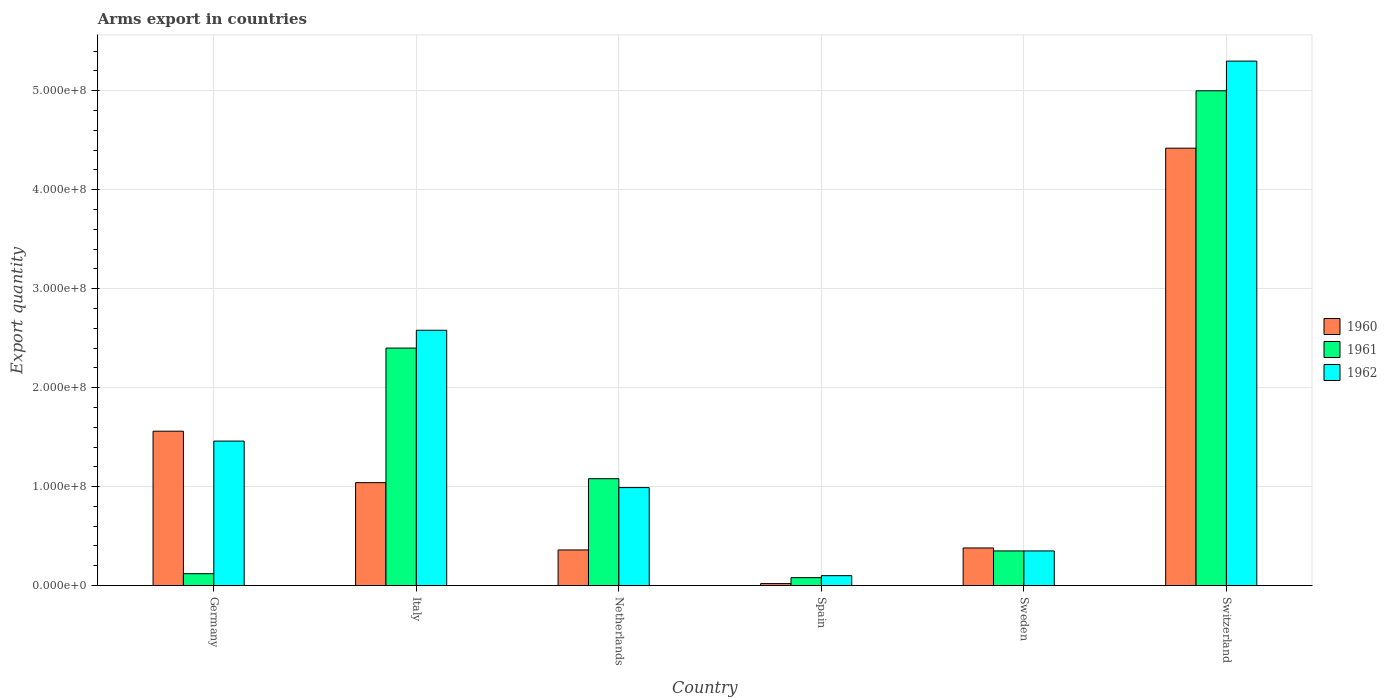How many different coloured bars are there?
Give a very brief answer. 3. How many groups of bars are there?
Offer a very short reply. 6. Are the number of bars on each tick of the X-axis equal?
Your response must be concise. Yes. How many bars are there on the 2nd tick from the left?
Your answer should be compact. 3. What is the label of the 2nd group of bars from the left?
Your answer should be very brief. Italy. What is the total arms export in 1962 in Germany?
Ensure brevity in your answer.  1.46e+08. Across all countries, what is the maximum total arms export in 1962?
Give a very brief answer. 5.30e+08. In which country was the total arms export in 1962 maximum?
Your answer should be compact. Switzerland. In which country was the total arms export in 1961 minimum?
Make the answer very short. Spain. What is the total total arms export in 1962 in the graph?
Offer a terse response. 1.08e+09. What is the difference between the total arms export in 1960 in Spain and that in Sweden?
Your response must be concise. -3.60e+07. What is the difference between the total arms export in 1962 in Italy and the total arms export in 1961 in Germany?
Keep it short and to the point. 2.46e+08. What is the average total arms export in 1961 per country?
Offer a terse response. 1.50e+08. What is the difference between the total arms export of/in 1962 and total arms export of/in 1960 in Italy?
Your answer should be compact. 1.54e+08. What is the ratio of the total arms export in 1962 in Netherlands to that in Switzerland?
Keep it short and to the point. 0.19. Is the total arms export in 1962 in Germany less than that in Spain?
Provide a short and direct response. No. Is the difference between the total arms export in 1962 in Italy and Netherlands greater than the difference between the total arms export in 1960 in Italy and Netherlands?
Offer a terse response. Yes. What is the difference between the highest and the second highest total arms export in 1962?
Your response must be concise. 3.84e+08. What is the difference between the highest and the lowest total arms export in 1960?
Your answer should be very brief. 4.40e+08. In how many countries, is the total arms export in 1961 greater than the average total arms export in 1961 taken over all countries?
Provide a short and direct response. 2. Is the sum of the total arms export in 1960 in Sweden and Switzerland greater than the maximum total arms export in 1962 across all countries?
Give a very brief answer. No. What does the 2nd bar from the right in Switzerland represents?
Provide a short and direct response. 1961. Are all the bars in the graph horizontal?
Provide a short and direct response. No. How many countries are there in the graph?
Provide a succinct answer. 6. What is the difference between two consecutive major ticks on the Y-axis?
Offer a very short reply. 1.00e+08. Are the values on the major ticks of Y-axis written in scientific E-notation?
Offer a very short reply. Yes. Does the graph contain grids?
Offer a terse response. Yes. Where does the legend appear in the graph?
Make the answer very short. Center right. What is the title of the graph?
Offer a terse response. Arms export in countries. What is the label or title of the X-axis?
Provide a short and direct response. Country. What is the label or title of the Y-axis?
Provide a succinct answer. Export quantity. What is the Export quantity of 1960 in Germany?
Your response must be concise. 1.56e+08. What is the Export quantity of 1961 in Germany?
Provide a succinct answer. 1.20e+07. What is the Export quantity of 1962 in Germany?
Make the answer very short. 1.46e+08. What is the Export quantity in 1960 in Italy?
Your answer should be very brief. 1.04e+08. What is the Export quantity of 1961 in Italy?
Your answer should be very brief. 2.40e+08. What is the Export quantity of 1962 in Italy?
Offer a very short reply. 2.58e+08. What is the Export quantity of 1960 in Netherlands?
Offer a terse response. 3.60e+07. What is the Export quantity in 1961 in Netherlands?
Provide a short and direct response. 1.08e+08. What is the Export quantity of 1962 in Netherlands?
Offer a terse response. 9.90e+07. What is the Export quantity in 1960 in Spain?
Provide a succinct answer. 2.00e+06. What is the Export quantity in 1960 in Sweden?
Offer a very short reply. 3.80e+07. What is the Export quantity in 1961 in Sweden?
Your answer should be very brief. 3.50e+07. What is the Export quantity of 1962 in Sweden?
Keep it short and to the point. 3.50e+07. What is the Export quantity of 1960 in Switzerland?
Make the answer very short. 4.42e+08. What is the Export quantity in 1961 in Switzerland?
Your answer should be very brief. 5.00e+08. What is the Export quantity of 1962 in Switzerland?
Your answer should be compact. 5.30e+08. Across all countries, what is the maximum Export quantity of 1960?
Provide a short and direct response. 4.42e+08. Across all countries, what is the maximum Export quantity of 1962?
Your answer should be compact. 5.30e+08. Across all countries, what is the minimum Export quantity in 1960?
Your answer should be very brief. 2.00e+06. Across all countries, what is the minimum Export quantity in 1961?
Offer a terse response. 8.00e+06. Across all countries, what is the minimum Export quantity in 1962?
Provide a succinct answer. 1.00e+07. What is the total Export quantity in 1960 in the graph?
Provide a short and direct response. 7.78e+08. What is the total Export quantity in 1961 in the graph?
Make the answer very short. 9.03e+08. What is the total Export quantity in 1962 in the graph?
Your answer should be very brief. 1.08e+09. What is the difference between the Export quantity in 1960 in Germany and that in Italy?
Ensure brevity in your answer.  5.20e+07. What is the difference between the Export quantity of 1961 in Germany and that in Italy?
Give a very brief answer. -2.28e+08. What is the difference between the Export quantity of 1962 in Germany and that in Italy?
Your answer should be very brief. -1.12e+08. What is the difference between the Export quantity in 1960 in Germany and that in Netherlands?
Offer a terse response. 1.20e+08. What is the difference between the Export quantity in 1961 in Germany and that in Netherlands?
Keep it short and to the point. -9.60e+07. What is the difference between the Export quantity of 1962 in Germany and that in Netherlands?
Your response must be concise. 4.70e+07. What is the difference between the Export quantity of 1960 in Germany and that in Spain?
Ensure brevity in your answer.  1.54e+08. What is the difference between the Export quantity of 1962 in Germany and that in Spain?
Offer a terse response. 1.36e+08. What is the difference between the Export quantity in 1960 in Germany and that in Sweden?
Offer a very short reply. 1.18e+08. What is the difference between the Export quantity of 1961 in Germany and that in Sweden?
Your response must be concise. -2.30e+07. What is the difference between the Export quantity of 1962 in Germany and that in Sweden?
Your response must be concise. 1.11e+08. What is the difference between the Export quantity of 1960 in Germany and that in Switzerland?
Ensure brevity in your answer.  -2.86e+08. What is the difference between the Export quantity in 1961 in Germany and that in Switzerland?
Offer a terse response. -4.88e+08. What is the difference between the Export quantity in 1962 in Germany and that in Switzerland?
Keep it short and to the point. -3.84e+08. What is the difference between the Export quantity of 1960 in Italy and that in Netherlands?
Make the answer very short. 6.80e+07. What is the difference between the Export quantity in 1961 in Italy and that in Netherlands?
Your response must be concise. 1.32e+08. What is the difference between the Export quantity of 1962 in Italy and that in Netherlands?
Your response must be concise. 1.59e+08. What is the difference between the Export quantity in 1960 in Italy and that in Spain?
Your answer should be compact. 1.02e+08. What is the difference between the Export quantity in 1961 in Italy and that in Spain?
Offer a terse response. 2.32e+08. What is the difference between the Export quantity in 1962 in Italy and that in Spain?
Your answer should be very brief. 2.48e+08. What is the difference between the Export quantity in 1960 in Italy and that in Sweden?
Offer a very short reply. 6.60e+07. What is the difference between the Export quantity of 1961 in Italy and that in Sweden?
Ensure brevity in your answer.  2.05e+08. What is the difference between the Export quantity of 1962 in Italy and that in Sweden?
Your response must be concise. 2.23e+08. What is the difference between the Export quantity of 1960 in Italy and that in Switzerland?
Provide a short and direct response. -3.38e+08. What is the difference between the Export quantity of 1961 in Italy and that in Switzerland?
Provide a short and direct response. -2.60e+08. What is the difference between the Export quantity in 1962 in Italy and that in Switzerland?
Provide a succinct answer. -2.72e+08. What is the difference between the Export quantity of 1960 in Netherlands and that in Spain?
Keep it short and to the point. 3.40e+07. What is the difference between the Export quantity in 1962 in Netherlands and that in Spain?
Keep it short and to the point. 8.90e+07. What is the difference between the Export quantity in 1961 in Netherlands and that in Sweden?
Your response must be concise. 7.30e+07. What is the difference between the Export quantity of 1962 in Netherlands and that in Sweden?
Ensure brevity in your answer.  6.40e+07. What is the difference between the Export quantity of 1960 in Netherlands and that in Switzerland?
Ensure brevity in your answer.  -4.06e+08. What is the difference between the Export quantity of 1961 in Netherlands and that in Switzerland?
Provide a short and direct response. -3.92e+08. What is the difference between the Export quantity of 1962 in Netherlands and that in Switzerland?
Provide a succinct answer. -4.31e+08. What is the difference between the Export quantity in 1960 in Spain and that in Sweden?
Your response must be concise. -3.60e+07. What is the difference between the Export quantity in 1961 in Spain and that in Sweden?
Your answer should be compact. -2.70e+07. What is the difference between the Export quantity of 1962 in Spain and that in Sweden?
Make the answer very short. -2.50e+07. What is the difference between the Export quantity of 1960 in Spain and that in Switzerland?
Provide a short and direct response. -4.40e+08. What is the difference between the Export quantity in 1961 in Spain and that in Switzerland?
Your answer should be very brief. -4.92e+08. What is the difference between the Export quantity in 1962 in Spain and that in Switzerland?
Offer a very short reply. -5.20e+08. What is the difference between the Export quantity in 1960 in Sweden and that in Switzerland?
Your response must be concise. -4.04e+08. What is the difference between the Export quantity in 1961 in Sweden and that in Switzerland?
Ensure brevity in your answer.  -4.65e+08. What is the difference between the Export quantity of 1962 in Sweden and that in Switzerland?
Offer a very short reply. -4.95e+08. What is the difference between the Export quantity in 1960 in Germany and the Export quantity in 1961 in Italy?
Make the answer very short. -8.40e+07. What is the difference between the Export quantity of 1960 in Germany and the Export quantity of 1962 in Italy?
Your response must be concise. -1.02e+08. What is the difference between the Export quantity of 1961 in Germany and the Export quantity of 1962 in Italy?
Make the answer very short. -2.46e+08. What is the difference between the Export quantity in 1960 in Germany and the Export quantity in 1961 in Netherlands?
Offer a terse response. 4.80e+07. What is the difference between the Export quantity of 1960 in Germany and the Export quantity of 1962 in Netherlands?
Offer a very short reply. 5.70e+07. What is the difference between the Export quantity in 1961 in Germany and the Export quantity in 1962 in Netherlands?
Provide a succinct answer. -8.70e+07. What is the difference between the Export quantity in 1960 in Germany and the Export quantity in 1961 in Spain?
Your answer should be very brief. 1.48e+08. What is the difference between the Export quantity of 1960 in Germany and the Export quantity of 1962 in Spain?
Keep it short and to the point. 1.46e+08. What is the difference between the Export quantity in 1961 in Germany and the Export quantity in 1962 in Spain?
Offer a very short reply. 2.00e+06. What is the difference between the Export quantity in 1960 in Germany and the Export quantity in 1961 in Sweden?
Your answer should be very brief. 1.21e+08. What is the difference between the Export quantity in 1960 in Germany and the Export quantity in 1962 in Sweden?
Offer a very short reply. 1.21e+08. What is the difference between the Export quantity in 1961 in Germany and the Export quantity in 1962 in Sweden?
Give a very brief answer. -2.30e+07. What is the difference between the Export quantity in 1960 in Germany and the Export quantity in 1961 in Switzerland?
Give a very brief answer. -3.44e+08. What is the difference between the Export quantity of 1960 in Germany and the Export quantity of 1962 in Switzerland?
Your answer should be compact. -3.74e+08. What is the difference between the Export quantity of 1961 in Germany and the Export quantity of 1962 in Switzerland?
Your answer should be compact. -5.18e+08. What is the difference between the Export quantity of 1961 in Italy and the Export quantity of 1962 in Netherlands?
Your answer should be compact. 1.41e+08. What is the difference between the Export quantity in 1960 in Italy and the Export quantity in 1961 in Spain?
Provide a succinct answer. 9.60e+07. What is the difference between the Export quantity of 1960 in Italy and the Export quantity of 1962 in Spain?
Your response must be concise. 9.40e+07. What is the difference between the Export quantity in 1961 in Italy and the Export quantity in 1962 in Spain?
Make the answer very short. 2.30e+08. What is the difference between the Export quantity of 1960 in Italy and the Export quantity of 1961 in Sweden?
Give a very brief answer. 6.90e+07. What is the difference between the Export quantity in 1960 in Italy and the Export quantity in 1962 in Sweden?
Your answer should be very brief. 6.90e+07. What is the difference between the Export quantity of 1961 in Italy and the Export quantity of 1962 in Sweden?
Provide a succinct answer. 2.05e+08. What is the difference between the Export quantity in 1960 in Italy and the Export quantity in 1961 in Switzerland?
Give a very brief answer. -3.96e+08. What is the difference between the Export quantity in 1960 in Italy and the Export quantity in 1962 in Switzerland?
Your answer should be compact. -4.26e+08. What is the difference between the Export quantity in 1961 in Italy and the Export quantity in 1962 in Switzerland?
Offer a terse response. -2.90e+08. What is the difference between the Export quantity in 1960 in Netherlands and the Export quantity in 1961 in Spain?
Your answer should be compact. 2.80e+07. What is the difference between the Export quantity in 1960 in Netherlands and the Export quantity in 1962 in Spain?
Keep it short and to the point. 2.60e+07. What is the difference between the Export quantity in 1961 in Netherlands and the Export quantity in 1962 in Spain?
Offer a terse response. 9.80e+07. What is the difference between the Export quantity of 1960 in Netherlands and the Export quantity of 1961 in Sweden?
Your response must be concise. 1.00e+06. What is the difference between the Export quantity in 1961 in Netherlands and the Export quantity in 1962 in Sweden?
Your answer should be very brief. 7.30e+07. What is the difference between the Export quantity in 1960 in Netherlands and the Export quantity in 1961 in Switzerland?
Keep it short and to the point. -4.64e+08. What is the difference between the Export quantity in 1960 in Netherlands and the Export quantity in 1962 in Switzerland?
Your answer should be very brief. -4.94e+08. What is the difference between the Export quantity in 1961 in Netherlands and the Export quantity in 1962 in Switzerland?
Give a very brief answer. -4.22e+08. What is the difference between the Export quantity of 1960 in Spain and the Export quantity of 1961 in Sweden?
Provide a succinct answer. -3.30e+07. What is the difference between the Export quantity in 1960 in Spain and the Export quantity in 1962 in Sweden?
Provide a short and direct response. -3.30e+07. What is the difference between the Export quantity in 1961 in Spain and the Export quantity in 1962 in Sweden?
Provide a short and direct response. -2.70e+07. What is the difference between the Export quantity of 1960 in Spain and the Export quantity of 1961 in Switzerland?
Offer a terse response. -4.98e+08. What is the difference between the Export quantity of 1960 in Spain and the Export quantity of 1962 in Switzerland?
Provide a short and direct response. -5.28e+08. What is the difference between the Export quantity of 1961 in Spain and the Export quantity of 1962 in Switzerland?
Ensure brevity in your answer.  -5.22e+08. What is the difference between the Export quantity of 1960 in Sweden and the Export quantity of 1961 in Switzerland?
Provide a short and direct response. -4.62e+08. What is the difference between the Export quantity of 1960 in Sweden and the Export quantity of 1962 in Switzerland?
Give a very brief answer. -4.92e+08. What is the difference between the Export quantity in 1961 in Sweden and the Export quantity in 1962 in Switzerland?
Provide a succinct answer. -4.95e+08. What is the average Export quantity of 1960 per country?
Your response must be concise. 1.30e+08. What is the average Export quantity of 1961 per country?
Your answer should be compact. 1.50e+08. What is the average Export quantity of 1962 per country?
Ensure brevity in your answer.  1.80e+08. What is the difference between the Export quantity in 1960 and Export quantity in 1961 in Germany?
Provide a succinct answer. 1.44e+08. What is the difference between the Export quantity of 1961 and Export quantity of 1962 in Germany?
Ensure brevity in your answer.  -1.34e+08. What is the difference between the Export quantity of 1960 and Export quantity of 1961 in Italy?
Your answer should be compact. -1.36e+08. What is the difference between the Export quantity in 1960 and Export quantity in 1962 in Italy?
Offer a very short reply. -1.54e+08. What is the difference between the Export quantity in 1961 and Export quantity in 1962 in Italy?
Provide a succinct answer. -1.80e+07. What is the difference between the Export quantity of 1960 and Export quantity of 1961 in Netherlands?
Make the answer very short. -7.20e+07. What is the difference between the Export quantity in 1960 and Export quantity in 1962 in Netherlands?
Ensure brevity in your answer.  -6.30e+07. What is the difference between the Export quantity of 1961 and Export quantity of 1962 in Netherlands?
Your answer should be very brief. 9.00e+06. What is the difference between the Export quantity in 1960 and Export quantity in 1961 in Spain?
Ensure brevity in your answer.  -6.00e+06. What is the difference between the Export quantity in 1960 and Export quantity in 1962 in Spain?
Offer a terse response. -8.00e+06. What is the difference between the Export quantity in 1960 and Export quantity in 1961 in Sweden?
Your answer should be compact. 3.00e+06. What is the difference between the Export quantity of 1960 and Export quantity of 1961 in Switzerland?
Your answer should be very brief. -5.80e+07. What is the difference between the Export quantity in 1960 and Export quantity in 1962 in Switzerland?
Provide a short and direct response. -8.80e+07. What is the difference between the Export quantity in 1961 and Export quantity in 1962 in Switzerland?
Provide a succinct answer. -3.00e+07. What is the ratio of the Export quantity in 1961 in Germany to that in Italy?
Your answer should be very brief. 0.05. What is the ratio of the Export quantity of 1962 in Germany to that in Italy?
Give a very brief answer. 0.57. What is the ratio of the Export quantity in 1960 in Germany to that in Netherlands?
Your answer should be compact. 4.33. What is the ratio of the Export quantity of 1961 in Germany to that in Netherlands?
Your response must be concise. 0.11. What is the ratio of the Export quantity of 1962 in Germany to that in Netherlands?
Provide a short and direct response. 1.47. What is the ratio of the Export quantity of 1961 in Germany to that in Spain?
Ensure brevity in your answer.  1.5. What is the ratio of the Export quantity of 1960 in Germany to that in Sweden?
Your answer should be compact. 4.11. What is the ratio of the Export quantity in 1961 in Germany to that in Sweden?
Provide a short and direct response. 0.34. What is the ratio of the Export quantity in 1962 in Germany to that in Sweden?
Your answer should be very brief. 4.17. What is the ratio of the Export quantity in 1960 in Germany to that in Switzerland?
Give a very brief answer. 0.35. What is the ratio of the Export quantity in 1961 in Germany to that in Switzerland?
Provide a succinct answer. 0.02. What is the ratio of the Export quantity of 1962 in Germany to that in Switzerland?
Give a very brief answer. 0.28. What is the ratio of the Export quantity in 1960 in Italy to that in Netherlands?
Your response must be concise. 2.89. What is the ratio of the Export quantity of 1961 in Italy to that in Netherlands?
Your answer should be very brief. 2.22. What is the ratio of the Export quantity in 1962 in Italy to that in Netherlands?
Provide a succinct answer. 2.61. What is the ratio of the Export quantity of 1960 in Italy to that in Spain?
Offer a very short reply. 52. What is the ratio of the Export quantity of 1962 in Italy to that in Spain?
Your response must be concise. 25.8. What is the ratio of the Export quantity in 1960 in Italy to that in Sweden?
Offer a terse response. 2.74. What is the ratio of the Export quantity of 1961 in Italy to that in Sweden?
Ensure brevity in your answer.  6.86. What is the ratio of the Export quantity of 1962 in Italy to that in Sweden?
Your response must be concise. 7.37. What is the ratio of the Export quantity of 1960 in Italy to that in Switzerland?
Ensure brevity in your answer.  0.24. What is the ratio of the Export quantity in 1961 in Italy to that in Switzerland?
Provide a succinct answer. 0.48. What is the ratio of the Export quantity in 1962 in Italy to that in Switzerland?
Your response must be concise. 0.49. What is the ratio of the Export quantity of 1960 in Netherlands to that in Spain?
Your answer should be very brief. 18. What is the ratio of the Export quantity of 1961 in Netherlands to that in Spain?
Offer a very short reply. 13.5. What is the ratio of the Export quantity of 1961 in Netherlands to that in Sweden?
Your answer should be very brief. 3.09. What is the ratio of the Export quantity of 1962 in Netherlands to that in Sweden?
Keep it short and to the point. 2.83. What is the ratio of the Export quantity in 1960 in Netherlands to that in Switzerland?
Make the answer very short. 0.08. What is the ratio of the Export quantity in 1961 in Netherlands to that in Switzerland?
Your answer should be very brief. 0.22. What is the ratio of the Export quantity of 1962 in Netherlands to that in Switzerland?
Your answer should be very brief. 0.19. What is the ratio of the Export quantity in 1960 in Spain to that in Sweden?
Make the answer very short. 0.05. What is the ratio of the Export quantity in 1961 in Spain to that in Sweden?
Offer a terse response. 0.23. What is the ratio of the Export quantity of 1962 in Spain to that in Sweden?
Ensure brevity in your answer.  0.29. What is the ratio of the Export quantity in 1960 in Spain to that in Switzerland?
Give a very brief answer. 0. What is the ratio of the Export quantity in 1961 in Spain to that in Switzerland?
Offer a terse response. 0.02. What is the ratio of the Export quantity in 1962 in Spain to that in Switzerland?
Make the answer very short. 0.02. What is the ratio of the Export quantity of 1960 in Sweden to that in Switzerland?
Offer a very short reply. 0.09. What is the ratio of the Export quantity of 1961 in Sweden to that in Switzerland?
Offer a very short reply. 0.07. What is the ratio of the Export quantity of 1962 in Sweden to that in Switzerland?
Provide a succinct answer. 0.07. What is the difference between the highest and the second highest Export quantity in 1960?
Your answer should be compact. 2.86e+08. What is the difference between the highest and the second highest Export quantity of 1961?
Your response must be concise. 2.60e+08. What is the difference between the highest and the second highest Export quantity of 1962?
Offer a very short reply. 2.72e+08. What is the difference between the highest and the lowest Export quantity in 1960?
Your answer should be compact. 4.40e+08. What is the difference between the highest and the lowest Export quantity of 1961?
Ensure brevity in your answer.  4.92e+08. What is the difference between the highest and the lowest Export quantity in 1962?
Provide a short and direct response. 5.20e+08. 